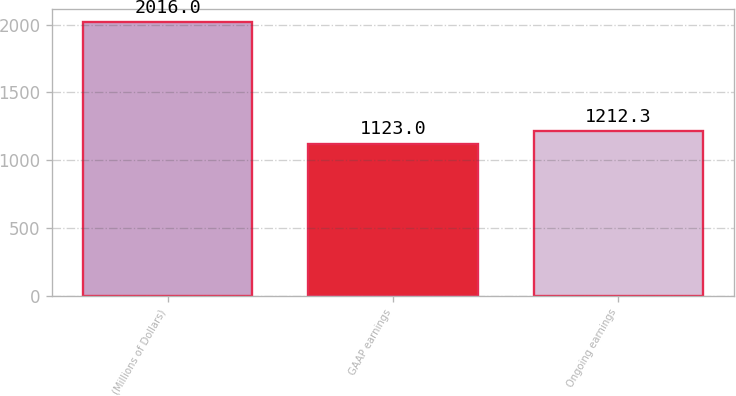<chart> <loc_0><loc_0><loc_500><loc_500><bar_chart><fcel>(Millions of Dollars)<fcel>GAAP earnings<fcel>Ongoing earnings<nl><fcel>2016<fcel>1123<fcel>1212.3<nl></chart> 